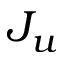<formula> <loc_0><loc_0><loc_500><loc_500>J _ { u }</formula> 